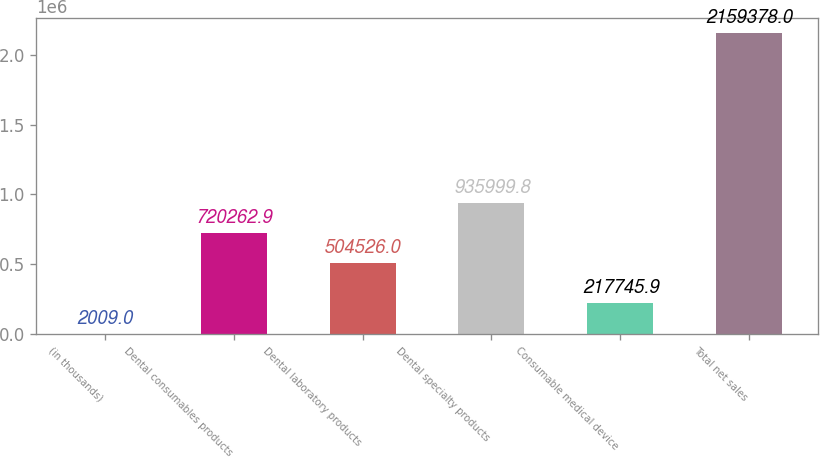Convert chart. <chart><loc_0><loc_0><loc_500><loc_500><bar_chart><fcel>(in thousands)<fcel>Dental consumables products<fcel>Dental laboratory products<fcel>Dental specialty products<fcel>Consumable medical device<fcel>Total net sales<nl><fcel>2009<fcel>720263<fcel>504526<fcel>936000<fcel>217746<fcel>2.15938e+06<nl></chart> 